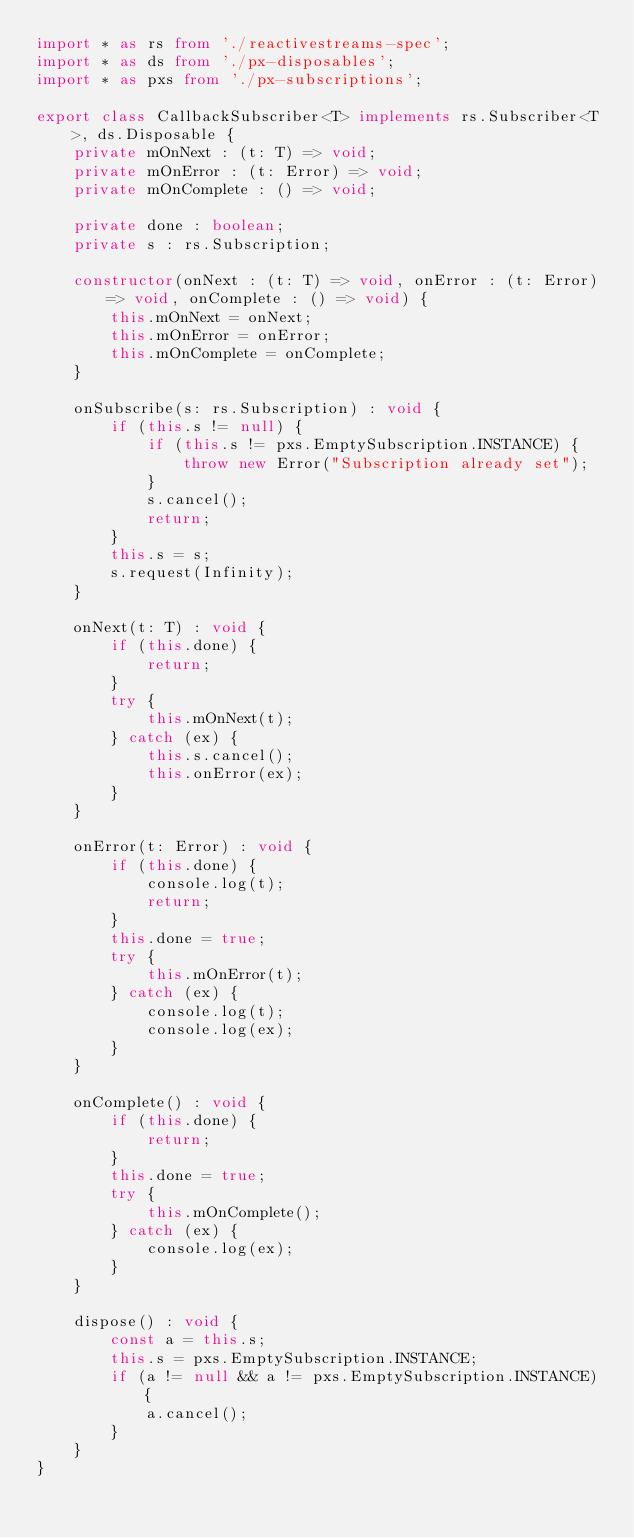Convert code to text. <code><loc_0><loc_0><loc_500><loc_500><_TypeScript_>import * as rs from './reactivestreams-spec';
import * as ds from './px-disposables';
import * as pxs from './px-subscriptions';

export class CallbackSubscriber<T> implements rs.Subscriber<T>, ds.Disposable {
    private mOnNext : (t: T) => void;
    private mOnError : (t: Error) => void;
    private mOnComplete : () => void;
    
    private done : boolean;
    private s : rs.Subscription;
    
    constructor(onNext : (t: T) => void, onError : (t: Error) => void, onComplete : () => void) {
        this.mOnNext = onNext;
        this.mOnError = onError;
        this.mOnComplete = onComplete;
    }
    
    onSubscribe(s: rs.Subscription) : void {
        if (this.s != null) {
            if (this.s != pxs.EmptySubscription.INSTANCE) {
                throw new Error("Subscription already set");
            }
            s.cancel();
            return;
        }
        this.s = s;
        s.request(Infinity);
    }
    
    onNext(t: T) : void {
        if (this.done) {
            return;
        }
        try {
            this.mOnNext(t);
        } catch (ex) {
            this.s.cancel();
            this.onError(ex);
        }
    }
    
    onError(t: Error) : void {
        if (this.done) {
            console.log(t);
            return;
        }
        this.done = true;
        try {
            this.mOnError(t);
        } catch (ex) {
            console.log(t);
            console.log(ex);
        }
    }
    
    onComplete() : void {
        if (this.done) {
            return;
        }
        this.done = true;
        try {
            this.mOnComplete();
        } catch (ex) {
            console.log(ex);
        }
    }
    
    dispose() : void {
        const a = this.s;
        this.s = pxs.EmptySubscription.INSTANCE;
        if (a != null && a != pxs.EmptySubscription.INSTANCE) {
            a.cancel();
        }
    }
}</code> 